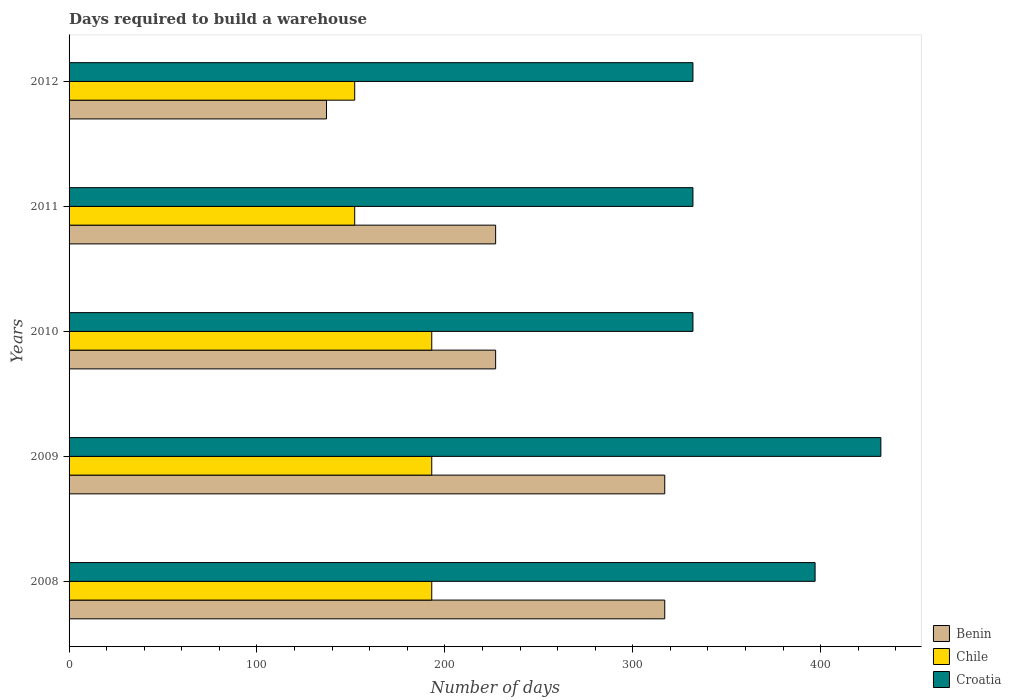How many groups of bars are there?
Ensure brevity in your answer.  5. Are the number of bars per tick equal to the number of legend labels?
Give a very brief answer. Yes. Are the number of bars on each tick of the Y-axis equal?
Your answer should be compact. Yes. What is the label of the 3rd group of bars from the top?
Your answer should be very brief. 2010. What is the days required to build a warehouse in in Benin in 2008?
Offer a terse response. 317. Across all years, what is the maximum days required to build a warehouse in in Chile?
Your response must be concise. 193. Across all years, what is the minimum days required to build a warehouse in in Benin?
Keep it short and to the point. 137. In which year was the days required to build a warehouse in in Croatia maximum?
Your response must be concise. 2009. In which year was the days required to build a warehouse in in Chile minimum?
Make the answer very short. 2011. What is the total days required to build a warehouse in in Benin in the graph?
Offer a terse response. 1225. What is the difference between the days required to build a warehouse in in Croatia in 2008 and that in 2009?
Offer a very short reply. -35. What is the difference between the days required to build a warehouse in in Croatia in 2010 and the days required to build a warehouse in in Chile in 2008?
Give a very brief answer. 139. What is the average days required to build a warehouse in in Croatia per year?
Offer a terse response. 365. In the year 2008, what is the difference between the days required to build a warehouse in in Benin and days required to build a warehouse in in Chile?
Provide a short and direct response. 124. What is the ratio of the days required to build a warehouse in in Chile in 2008 to that in 2011?
Offer a terse response. 1.27. What is the difference between the highest and the second highest days required to build a warehouse in in Chile?
Provide a succinct answer. 0. What is the difference between the highest and the lowest days required to build a warehouse in in Chile?
Ensure brevity in your answer.  41. Is the sum of the days required to build a warehouse in in Benin in 2008 and 2010 greater than the maximum days required to build a warehouse in in Croatia across all years?
Your answer should be very brief. Yes. What does the 3rd bar from the top in 2012 represents?
Offer a very short reply. Benin. What does the 2nd bar from the bottom in 2010 represents?
Your answer should be compact. Chile. Is it the case that in every year, the sum of the days required to build a warehouse in in Chile and days required to build a warehouse in in Benin is greater than the days required to build a warehouse in in Croatia?
Give a very brief answer. No. How many bars are there?
Your response must be concise. 15. Are all the bars in the graph horizontal?
Your response must be concise. Yes. Does the graph contain any zero values?
Offer a terse response. No. How are the legend labels stacked?
Give a very brief answer. Vertical. What is the title of the graph?
Keep it short and to the point. Days required to build a warehouse. What is the label or title of the X-axis?
Make the answer very short. Number of days. What is the label or title of the Y-axis?
Offer a very short reply. Years. What is the Number of days of Benin in 2008?
Offer a very short reply. 317. What is the Number of days of Chile in 2008?
Provide a succinct answer. 193. What is the Number of days of Croatia in 2008?
Provide a succinct answer. 397. What is the Number of days in Benin in 2009?
Offer a terse response. 317. What is the Number of days of Chile in 2009?
Offer a very short reply. 193. What is the Number of days of Croatia in 2009?
Provide a short and direct response. 432. What is the Number of days in Benin in 2010?
Provide a succinct answer. 227. What is the Number of days of Chile in 2010?
Provide a short and direct response. 193. What is the Number of days in Croatia in 2010?
Your response must be concise. 332. What is the Number of days of Benin in 2011?
Make the answer very short. 227. What is the Number of days of Chile in 2011?
Make the answer very short. 152. What is the Number of days of Croatia in 2011?
Offer a terse response. 332. What is the Number of days in Benin in 2012?
Offer a very short reply. 137. What is the Number of days of Chile in 2012?
Ensure brevity in your answer.  152. What is the Number of days of Croatia in 2012?
Your response must be concise. 332. Across all years, what is the maximum Number of days of Benin?
Ensure brevity in your answer.  317. Across all years, what is the maximum Number of days in Chile?
Your answer should be very brief. 193. Across all years, what is the maximum Number of days in Croatia?
Your answer should be compact. 432. Across all years, what is the minimum Number of days in Benin?
Ensure brevity in your answer.  137. Across all years, what is the minimum Number of days of Chile?
Your answer should be very brief. 152. Across all years, what is the minimum Number of days of Croatia?
Give a very brief answer. 332. What is the total Number of days of Benin in the graph?
Give a very brief answer. 1225. What is the total Number of days of Chile in the graph?
Keep it short and to the point. 883. What is the total Number of days in Croatia in the graph?
Offer a very short reply. 1825. What is the difference between the Number of days in Croatia in 2008 and that in 2009?
Your answer should be compact. -35. What is the difference between the Number of days of Benin in 2008 and that in 2011?
Keep it short and to the point. 90. What is the difference between the Number of days in Benin in 2008 and that in 2012?
Offer a terse response. 180. What is the difference between the Number of days of Chile in 2008 and that in 2012?
Offer a terse response. 41. What is the difference between the Number of days in Croatia in 2008 and that in 2012?
Ensure brevity in your answer.  65. What is the difference between the Number of days in Benin in 2009 and that in 2010?
Provide a short and direct response. 90. What is the difference between the Number of days in Croatia in 2009 and that in 2010?
Your answer should be compact. 100. What is the difference between the Number of days of Benin in 2009 and that in 2012?
Offer a terse response. 180. What is the difference between the Number of days in Chile in 2010 and that in 2012?
Your answer should be compact. 41. What is the difference between the Number of days in Chile in 2011 and that in 2012?
Offer a terse response. 0. What is the difference between the Number of days in Benin in 2008 and the Number of days in Chile in 2009?
Your answer should be very brief. 124. What is the difference between the Number of days in Benin in 2008 and the Number of days in Croatia in 2009?
Your answer should be very brief. -115. What is the difference between the Number of days in Chile in 2008 and the Number of days in Croatia in 2009?
Your response must be concise. -239. What is the difference between the Number of days in Benin in 2008 and the Number of days in Chile in 2010?
Provide a short and direct response. 124. What is the difference between the Number of days of Benin in 2008 and the Number of days of Croatia in 2010?
Provide a short and direct response. -15. What is the difference between the Number of days in Chile in 2008 and the Number of days in Croatia in 2010?
Offer a terse response. -139. What is the difference between the Number of days in Benin in 2008 and the Number of days in Chile in 2011?
Offer a terse response. 165. What is the difference between the Number of days of Chile in 2008 and the Number of days of Croatia in 2011?
Ensure brevity in your answer.  -139. What is the difference between the Number of days of Benin in 2008 and the Number of days of Chile in 2012?
Keep it short and to the point. 165. What is the difference between the Number of days of Chile in 2008 and the Number of days of Croatia in 2012?
Your answer should be very brief. -139. What is the difference between the Number of days in Benin in 2009 and the Number of days in Chile in 2010?
Provide a succinct answer. 124. What is the difference between the Number of days in Chile in 2009 and the Number of days in Croatia in 2010?
Provide a succinct answer. -139. What is the difference between the Number of days in Benin in 2009 and the Number of days in Chile in 2011?
Your answer should be very brief. 165. What is the difference between the Number of days in Chile in 2009 and the Number of days in Croatia in 2011?
Keep it short and to the point. -139. What is the difference between the Number of days in Benin in 2009 and the Number of days in Chile in 2012?
Offer a terse response. 165. What is the difference between the Number of days in Chile in 2009 and the Number of days in Croatia in 2012?
Offer a terse response. -139. What is the difference between the Number of days of Benin in 2010 and the Number of days of Croatia in 2011?
Your response must be concise. -105. What is the difference between the Number of days in Chile in 2010 and the Number of days in Croatia in 2011?
Make the answer very short. -139. What is the difference between the Number of days in Benin in 2010 and the Number of days in Croatia in 2012?
Offer a very short reply. -105. What is the difference between the Number of days of Chile in 2010 and the Number of days of Croatia in 2012?
Provide a succinct answer. -139. What is the difference between the Number of days of Benin in 2011 and the Number of days of Croatia in 2012?
Provide a succinct answer. -105. What is the difference between the Number of days of Chile in 2011 and the Number of days of Croatia in 2012?
Your response must be concise. -180. What is the average Number of days in Benin per year?
Provide a short and direct response. 245. What is the average Number of days of Chile per year?
Make the answer very short. 176.6. What is the average Number of days of Croatia per year?
Ensure brevity in your answer.  365. In the year 2008, what is the difference between the Number of days of Benin and Number of days of Chile?
Your answer should be very brief. 124. In the year 2008, what is the difference between the Number of days of Benin and Number of days of Croatia?
Make the answer very short. -80. In the year 2008, what is the difference between the Number of days of Chile and Number of days of Croatia?
Provide a succinct answer. -204. In the year 2009, what is the difference between the Number of days of Benin and Number of days of Chile?
Your answer should be very brief. 124. In the year 2009, what is the difference between the Number of days in Benin and Number of days in Croatia?
Ensure brevity in your answer.  -115. In the year 2009, what is the difference between the Number of days in Chile and Number of days in Croatia?
Your response must be concise. -239. In the year 2010, what is the difference between the Number of days in Benin and Number of days in Croatia?
Offer a terse response. -105. In the year 2010, what is the difference between the Number of days in Chile and Number of days in Croatia?
Offer a terse response. -139. In the year 2011, what is the difference between the Number of days of Benin and Number of days of Croatia?
Your answer should be compact. -105. In the year 2011, what is the difference between the Number of days in Chile and Number of days in Croatia?
Give a very brief answer. -180. In the year 2012, what is the difference between the Number of days of Benin and Number of days of Chile?
Offer a very short reply. -15. In the year 2012, what is the difference between the Number of days in Benin and Number of days in Croatia?
Offer a terse response. -195. In the year 2012, what is the difference between the Number of days of Chile and Number of days of Croatia?
Provide a succinct answer. -180. What is the ratio of the Number of days in Benin in 2008 to that in 2009?
Provide a succinct answer. 1. What is the ratio of the Number of days in Croatia in 2008 to that in 2009?
Offer a terse response. 0.92. What is the ratio of the Number of days of Benin in 2008 to that in 2010?
Offer a very short reply. 1.4. What is the ratio of the Number of days in Croatia in 2008 to that in 2010?
Offer a very short reply. 1.2. What is the ratio of the Number of days of Benin in 2008 to that in 2011?
Keep it short and to the point. 1.4. What is the ratio of the Number of days of Chile in 2008 to that in 2011?
Provide a short and direct response. 1.27. What is the ratio of the Number of days of Croatia in 2008 to that in 2011?
Offer a terse response. 1.2. What is the ratio of the Number of days in Benin in 2008 to that in 2012?
Give a very brief answer. 2.31. What is the ratio of the Number of days in Chile in 2008 to that in 2012?
Give a very brief answer. 1.27. What is the ratio of the Number of days in Croatia in 2008 to that in 2012?
Offer a terse response. 1.2. What is the ratio of the Number of days of Benin in 2009 to that in 2010?
Offer a very short reply. 1.4. What is the ratio of the Number of days in Chile in 2009 to that in 2010?
Your response must be concise. 1. What is the ratio of the Number of days of Croatia in 2009 to that in 2010?
Your answer should be compact. 1.3. What is the ratio of the Number of days of Benin in 2009 to that in 2011?
Provide a short and direct response. 1.4. What is the ratio of the Number of days in Chile in 2009 to that in 2011?
Make the answer very short. 1.27. What is the ratio of the Number of days of Croatia in 2009 to that in 2011?
Your response must be concise. 1.3. What is the ratio of the Number of days in Benin in 2009 to that in 2012?
Give a very brief answer. 2.31. What is the ratio of the Number of days of Chile in 2009 to that in 2012?
Your response must be concise. 1.27. What is the ratio of the Number of days in Croatia in 2009 to that in 2012?
Provide a short and direct response. 1.3. What is the ratio of the Number of days in Benin in 2010 to that in 2011?
Ensure brevity in your answer.  1. What is the ratio of the Number of days in Chile in 2010 to that in 2011?
Provide a short and direct response. 1.27. What is the ratio of the Number of days of Croatia in 2010 to that in 2011?
Your response must be concise. 1. What is the ratio of the Number of days of Benin in 2010 to that in 2012?
Keep it short and to the point. 1.66. What is the ratio of the Number of days in Chile in 2010 to that in 2012?
Offer a very short reply. 1.27. What is the ratio of the Number of days of Benin in 2011 to that in 2012?
Ensure brevity in your answer.  1.66. What is the ratio of the Number of days in Chile in 2011 to that in 2012?
Keep it short and to the point. 1. What is the difference between the highest and the second highest Number of days in Benin?
Keep it short and to the point. 0. What is the difference between the highest and the second highest Number of days in Chile?
Ensure brevity in your answer.  0. What is the difference between the highest and the second highest Number of days in Croatia?
Your answer should be very brief. 35. What is the difference between the highest and the lowest Number of days in Benin?
Ensure brevity in your answer.  180. What is the difference between the highest and the lowest Number of days of Chile?
Offer a very short reply. 41. What is the difference between the highest and the lowest Number of days of Croatia?
Offer a terse response. 100. 